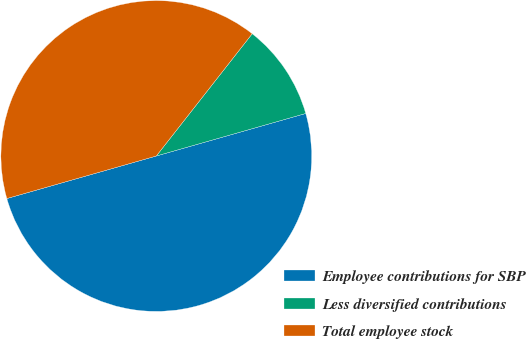Convert chart to OTSL. <chart><loc_0><loc_0><loc_500><loc_500><pie_chart><fcel>Employee contributions for SBP<fcel>Less diversified contributions<fcel>Total employee stock<nl><fcel>50.0%<fcel>10.0%<fcel>40.0%<nl></chart> 